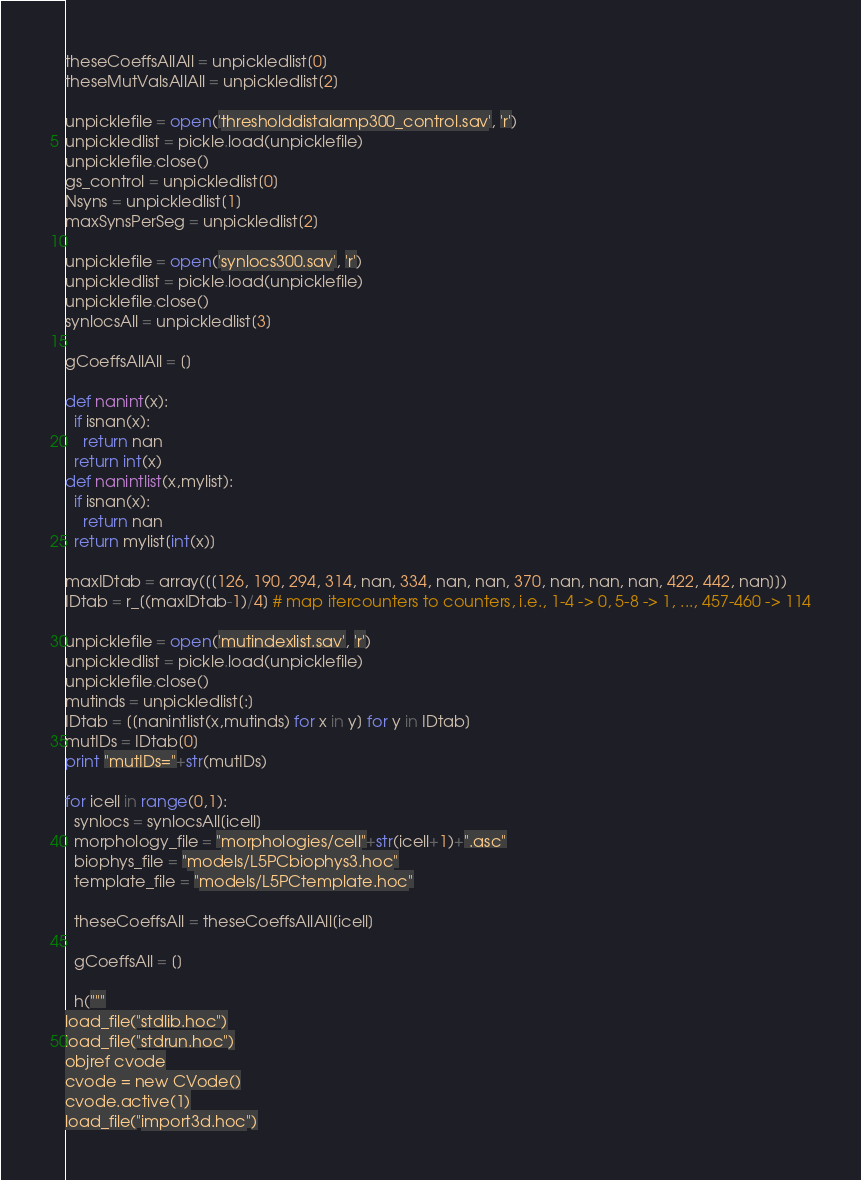Convert code to text. <code><loc_0><loc_0><loc_500><loc_500><_Python_>theseCoeffsAllAll = unpickledlist[0]
theseMutValsAllAll = unpickledlist[2]

unpicklefile = open('thresholddistalamp300_control.sav', 'r')
unpickledlist = pickle.load(unpicklefile)
unpicklefile.close()
gs_control = unpickledlist[0]
Nsyns = unpickledlist[1]
maxSynsPerSeg = unpickledlist[2]

unpicklefile = open('synlocs300.sav', 'r')
unpickledlist = pickle.load(unpicklefile)
unpicklefile.close()
synlocsAll = unpickledlist[3]

gCoeffsAllAll = []

def nanint(x):
  if isnan(x):
    return nan
  return int(x)
def nanintlist(x,mylist):
  if isnan(x):
    return nan
  return mylist[int(x)]

maxIDtab = array([[126, 190, 294, 314, nan, 334, nan, nan, 370, nan, nan, nan, 422, 442, nan]])
IDtab = r_[(maxIDtab-1)/4] # map itercounters to counters, i.e., 1-4 -> 0, 5-8 -> 1, ..., 457-460 -> 114

unpicklefile = open('mutindexlist.sav', 'r')
unpickledlist = pickle.load(unpicklefile)
unpicklefile.close()
mutinds = unpickledlist[:]
IDtab = [[nanintlist(x,mutinds) for x in y] for y in IDtab]
mutIDs = IDtab[0]
print "mutIDs="+str(mutIDs)

for icell in range(0,1):
  synlocs = synlocsAll[icell]
  morphology_file = "morphologies/cell"+str(icell+1)+".asc"
  biophys_file = "models/L5PCbiophys3.hoc"
  template_file = "models/L5PCtemplate.hoc"

  theseCoeffsAll = theseCoeffsAllAll[icell]

  gCoeffsAll = []

  h("""
load_file("stdlib.hoc")
load_file("stdrun.hoc")
objref cvode
cvode = new CVode()
cvode.active(1)
load_file("import3d.hoc")</code> 